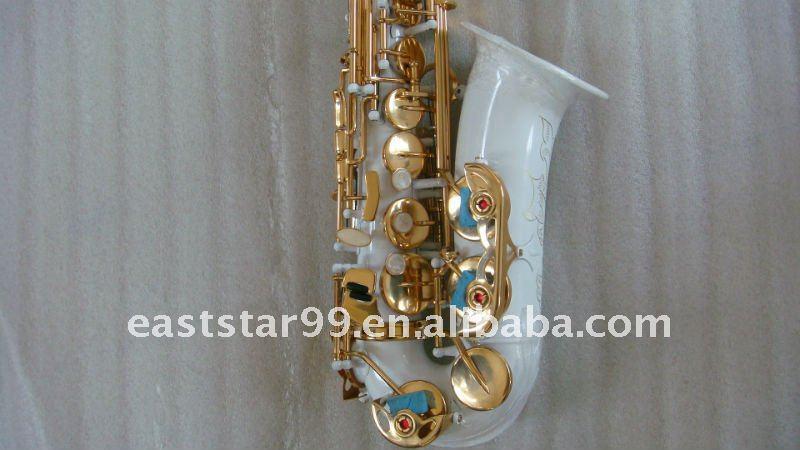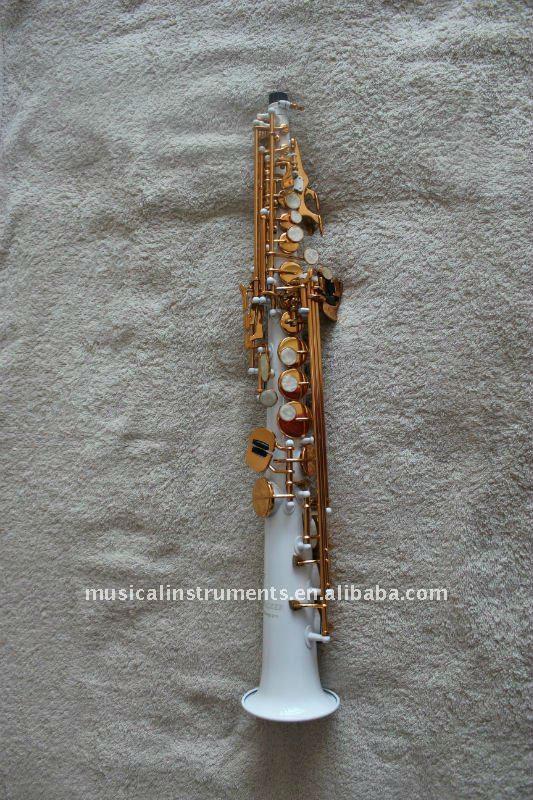The first image is the image on the left, the second image is the image on the right. Assess this claim about the two images: "The left image shows a white saxophone witht turquoise on its gold buttons and its upturned bell facing right, and the right image shows a straight white instrument with its bell at the bottom.". Correct or not? Answer yes or no. Yes. The first image is the image on the left, the second image is the image on the right. For the images shown, is this caption "In at least one image there is a single long horn that base is white and keys are brass." true? Answer yes or no. Yes. 